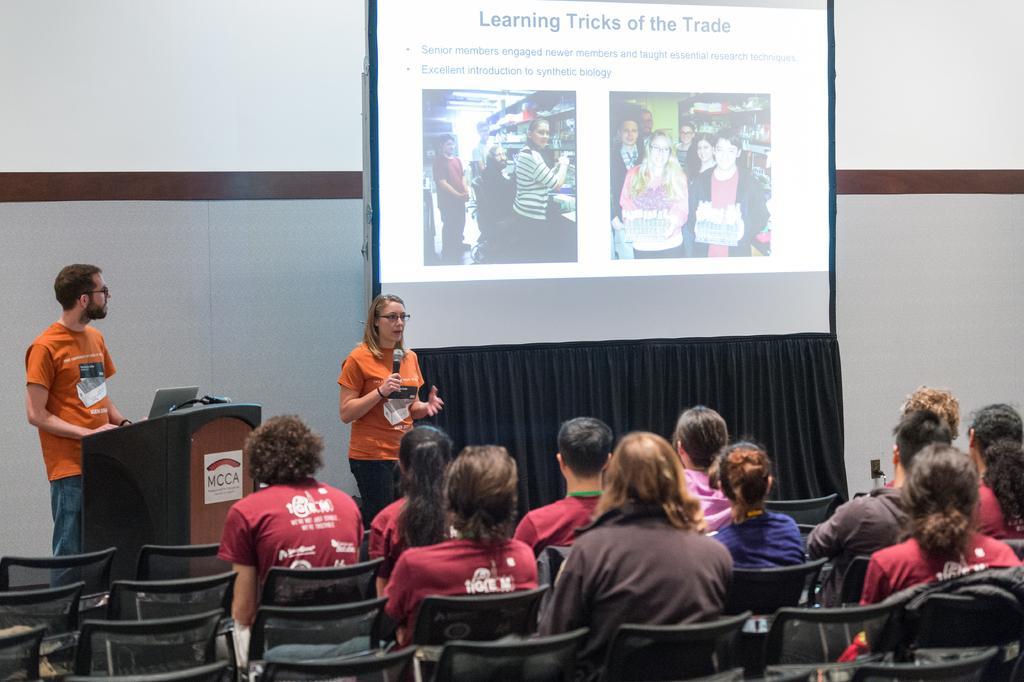How would you summarize this image in a sentence or two? In this picture there is a woman who is wearing t-shirt, trouser and spectacle. She is holding a mic. She is standing near to the projector screen. On the left there is a man who is standing near to the speech desk. On the desk we can see laptop and wires. On the bottom we can see group of person sitting on the chair. 